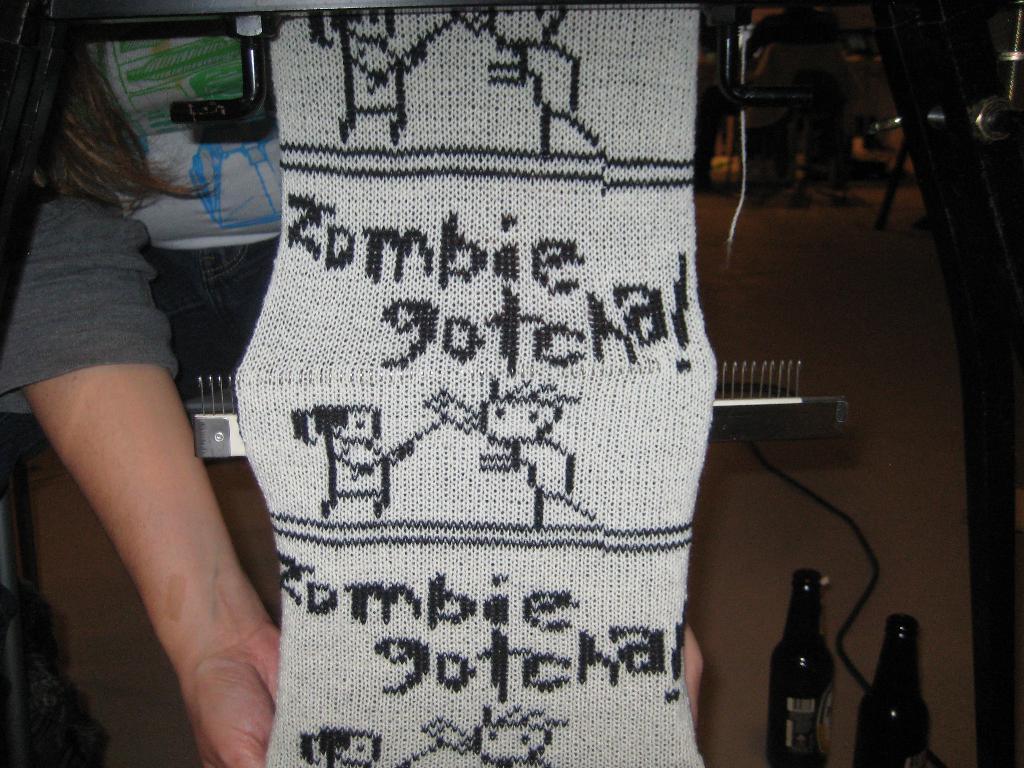Describe this image in one or two sentences. In this picture I can see a human and looks like a cloth weaving machine and I can see a cloth with some text on it and couple of bottles on the floor and I can see chairs in the background. 